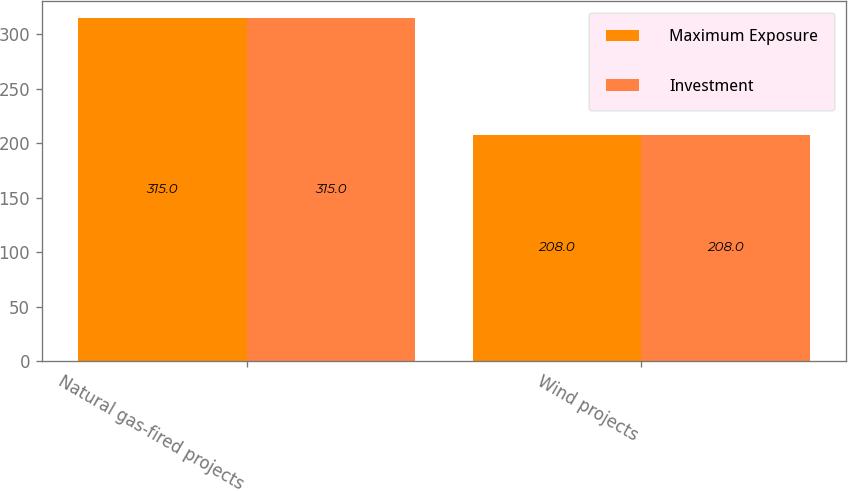<chart> <loc_0><loc_0><loc_500><loc_500><stacked_bar_chart><ecel><fcel>Natural gas-fired projects<fcel>Wind projects<nl><fcel>Maximum Exposure<fcel>315<fcel>208<nl><fcel>Investment<fcel>315<fcel>208<nl></chart> 